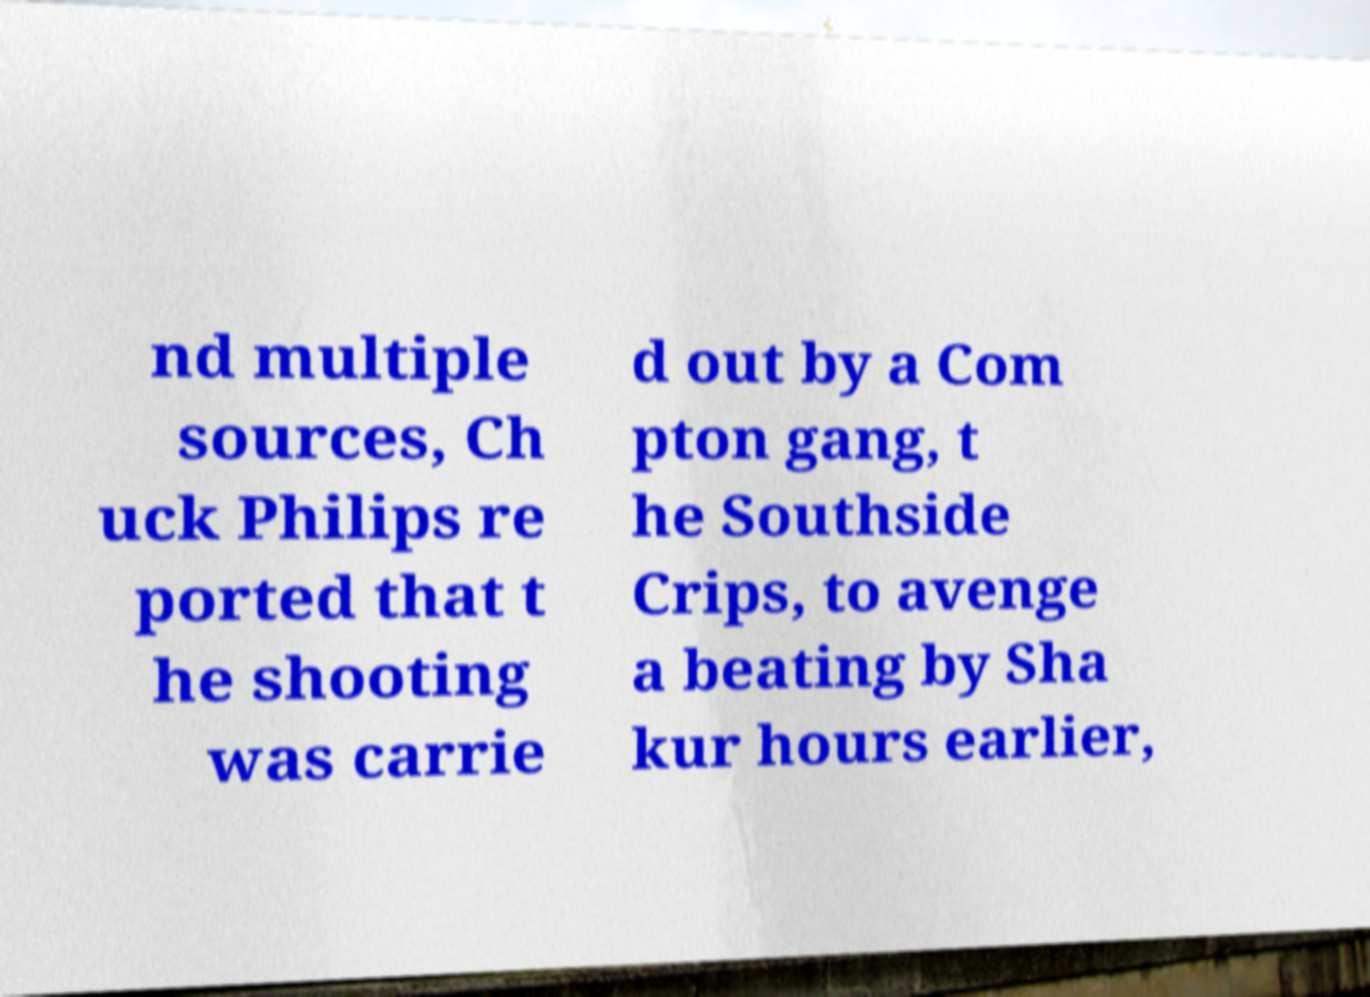What messages or text are displayed in this image? I need them in a readable, typed format. nd multiple sources, Ch uck Philips re ported that t he shooting was carrie d out by a Com pton gang, t he Southside Crips, to avenge a beating by Sha kur hours earlier, 